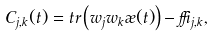Convert formula to latex. <formula><loc_0><loc_0><loc_500><loc_500>C _ { j , k } ( t ) = t r \left ( w _ { j } w _ { k } \rho ( t ) \right ) - \delta _ { j , k } ,</formula> 